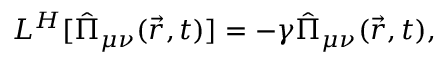<formula> <loc_0><loc_0><loc_500><loc_500>L ^ { H } [ \hat { \Pi } _ { \mu \nu } ( \vec { r } , t ) ] = - \gamma \hat { \Pi } _ { \mu \nu } ( \vec { r } , t ) ,</formula> 